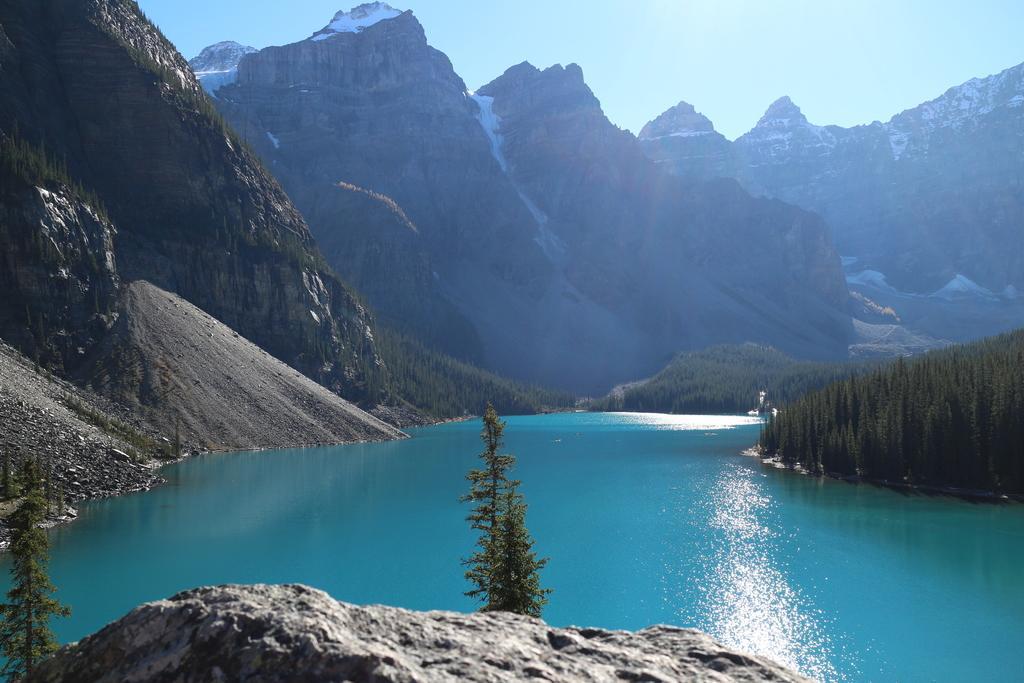Describe this image in one or two sentences. In this picture there is water in the center of the image and there are mountains and trees in the image. 